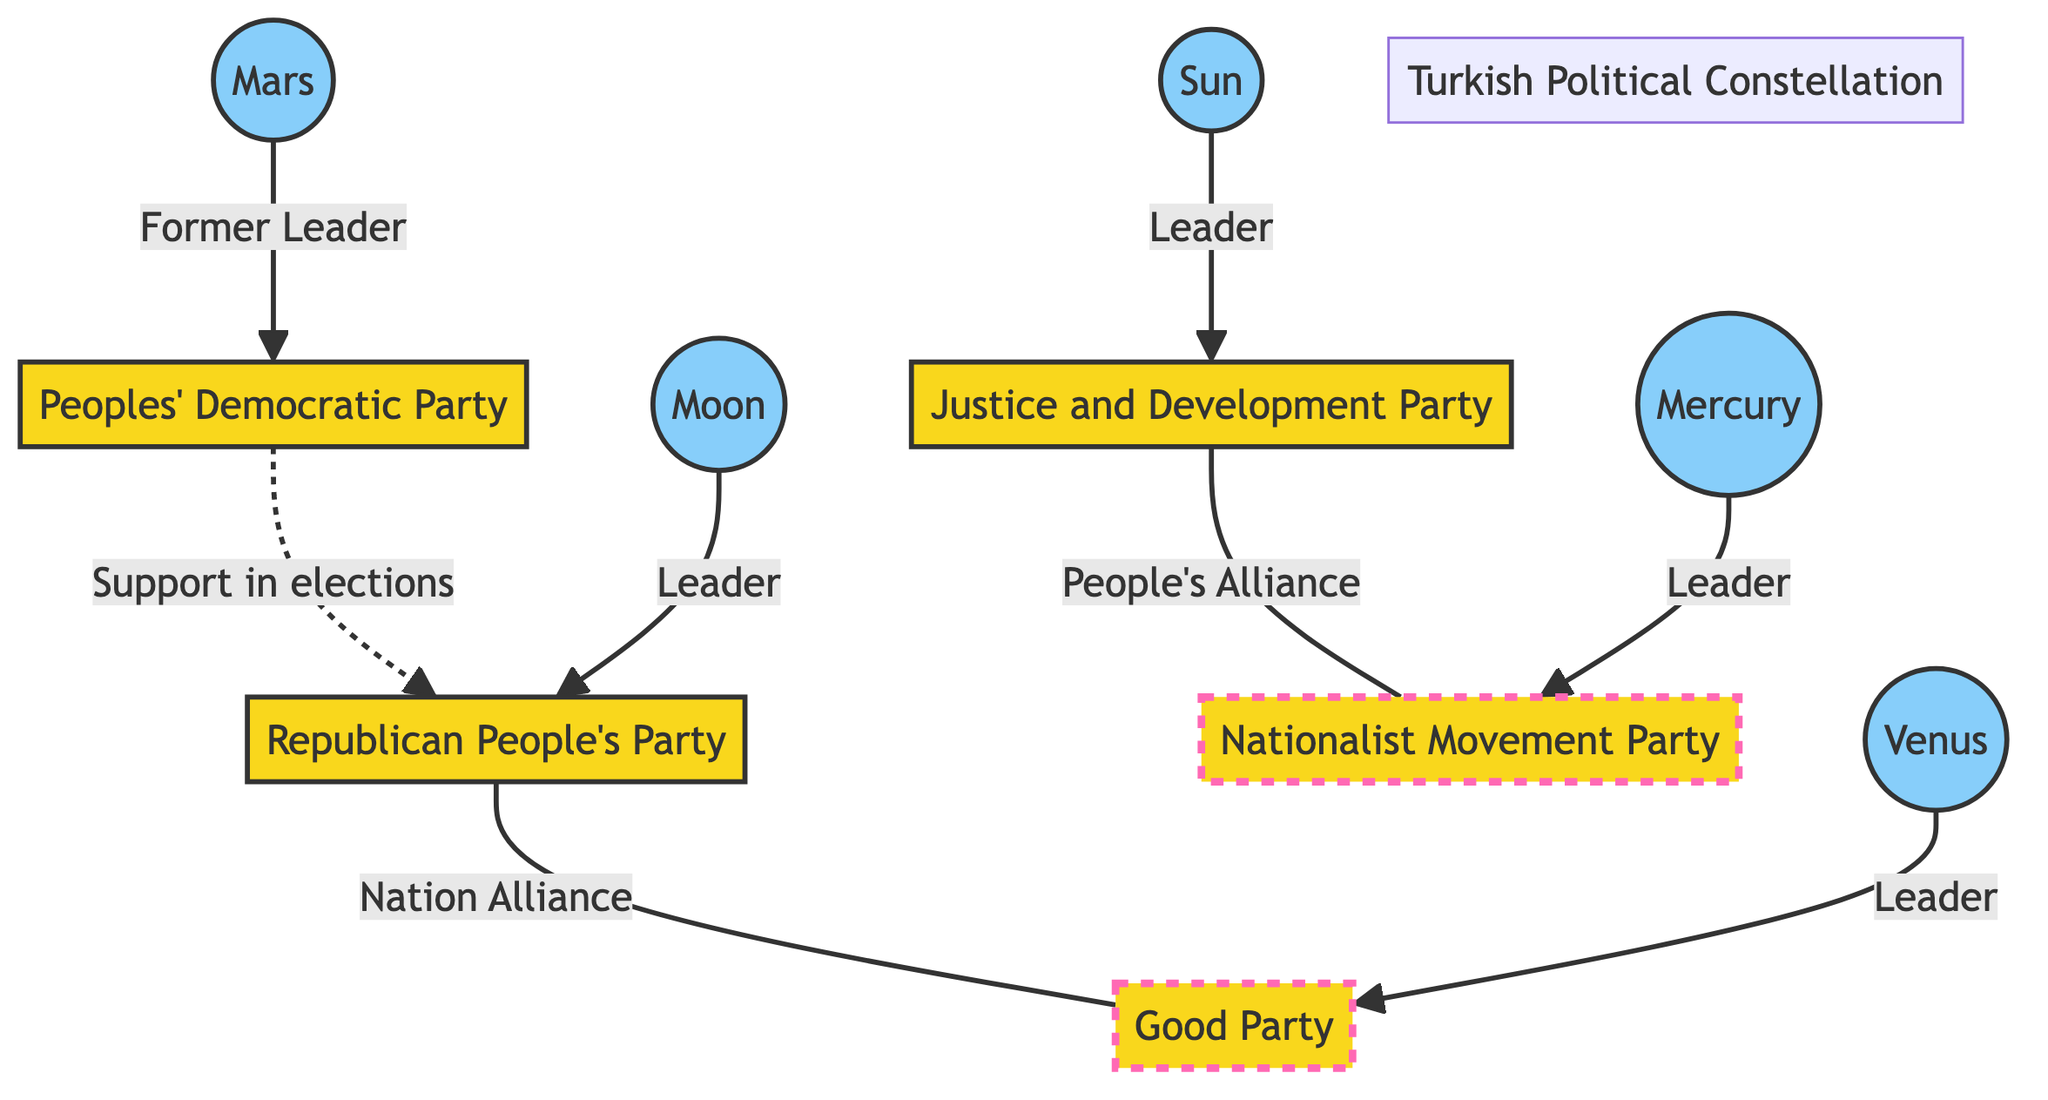What is the name of the alliance between the Justice and Development Party and the Nationalist Movement Party? The diagram clearly indicates a connection labeled "People's Alliance" between the Justice and Development Party (node 1) and the Nationalist Movement Party (node 3).
Answer: People's Alliance How many parties are represented in this diagram? There are five nodes representing political parties: Justice and Development Party, Republican People's Party, Nationalist Movement Party, Good Party, and Peoples' Democratic Party. Therefore, counting these nodes gives a total of five parties.
Answer: 5 Which celestial body indicates the leader of the Republican People's Party? The diagram shows a relationship where the Moon (node 7) is connected to the Republican People's Party (node 2) with a line indicating "Leader." Hence, the Moon represents the leader of this party.
Answer: Moon What type of connection is shown between the Peoples' Democratic Party and the Republican People's Party? The line between the Peoples' Democratic Party (node 5) and the Republican People's Party (node 2) is a dashed line, indicating "Support in elections." This suggests a supportive relationship rather than a formal alliance.
Answer: Support in elections Which celestial body denotes a former leader related to the Peoples' Democratic Party? The diagram specifies that the planet Mars (node 10) is connected to the Peoples' Democratic Party (node 5) with the label "Former Leader." Therefore, Mars denotes that former leader.
Answer: Mars What coalition is formed by the Good Party and the Republican People's Party? The diagram illustrates a relationship labeled "Nation Alliance" between the Republican People's Party (node 2) and the Good Party (node 4). This indicates their coalition formation.
Answer: Nation Alliance Which political party is indicated as a leader by the Sun? The diagram shows that the Sun (node 6) is connected to the Justice and Development Party (node 1) labeled "Leader." Therefore, the Justice and Development Party is the party associated with the Sun in terms of leadership.
Answer: Justice and Development Party What color is used to represent political parties in this diagram? The diagram uses the color fill #f9d71c for party nodes, as indicated by the class definitions at the beginning. This highlights political parties distinctly.
Answer: Yellow 